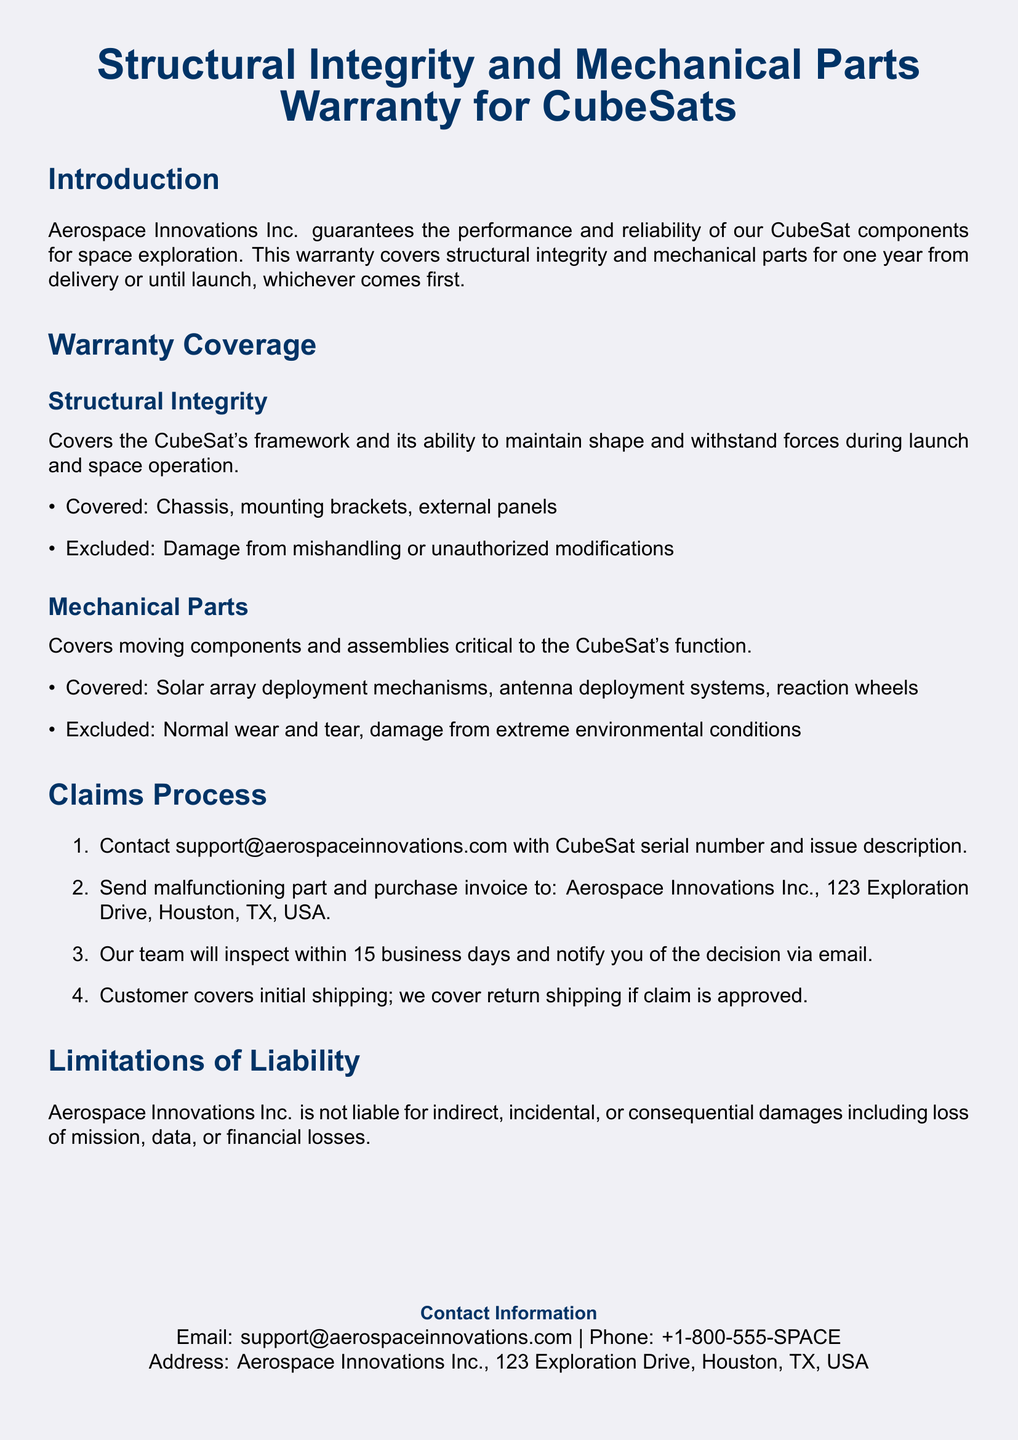What is the warranty duration for CubeSat components? The warranty duration is one year from delivery or until launch, whichever comes first.
Answer: one year Which company provides the warranty? The company providing the warranty is Aerospace Innovations Inc.
Answer: Aerospace Innovations Inc What components are covered under Structural Integrity? The covered components include chassis, mounting brackets, and external panels.
Answer: chassis, mounting brackets, external panels What should a customer do first to initiate a claim? The first step to initiate a claim is contacting support@aerospaceinnovations.com with the CubeSat serial number and issue description.
Answer: contact support What is excluded from the Mechanical Parts warranty? The exclusions for the Mechanical Parts warranty include normal wear and tear and damage from extreme environmental conditions.
Answer: normal wear and tear, damage from extreme environmental conditions How long does Aerospace Innovations take to inspect a claim? Aerospace Innovations inspects the claim within 15 business days.
Answer: 15 business days Who covers the initial shipping for the malfunctioning part? The customer covers the initial shipping of the malfunctioning part.
Answer: customer How can customers get in touch for support? Customers can contact support via email or phone provided in the document.
Answer: email or phone What is Aerospace Innovations Inc. not liable for? Aerospace Innovations Inc. is not liable for indirect, incidental, or consequential damages including loss of mission, data, or financial losses.
Answer: indirect, incidental, or consequential damages 